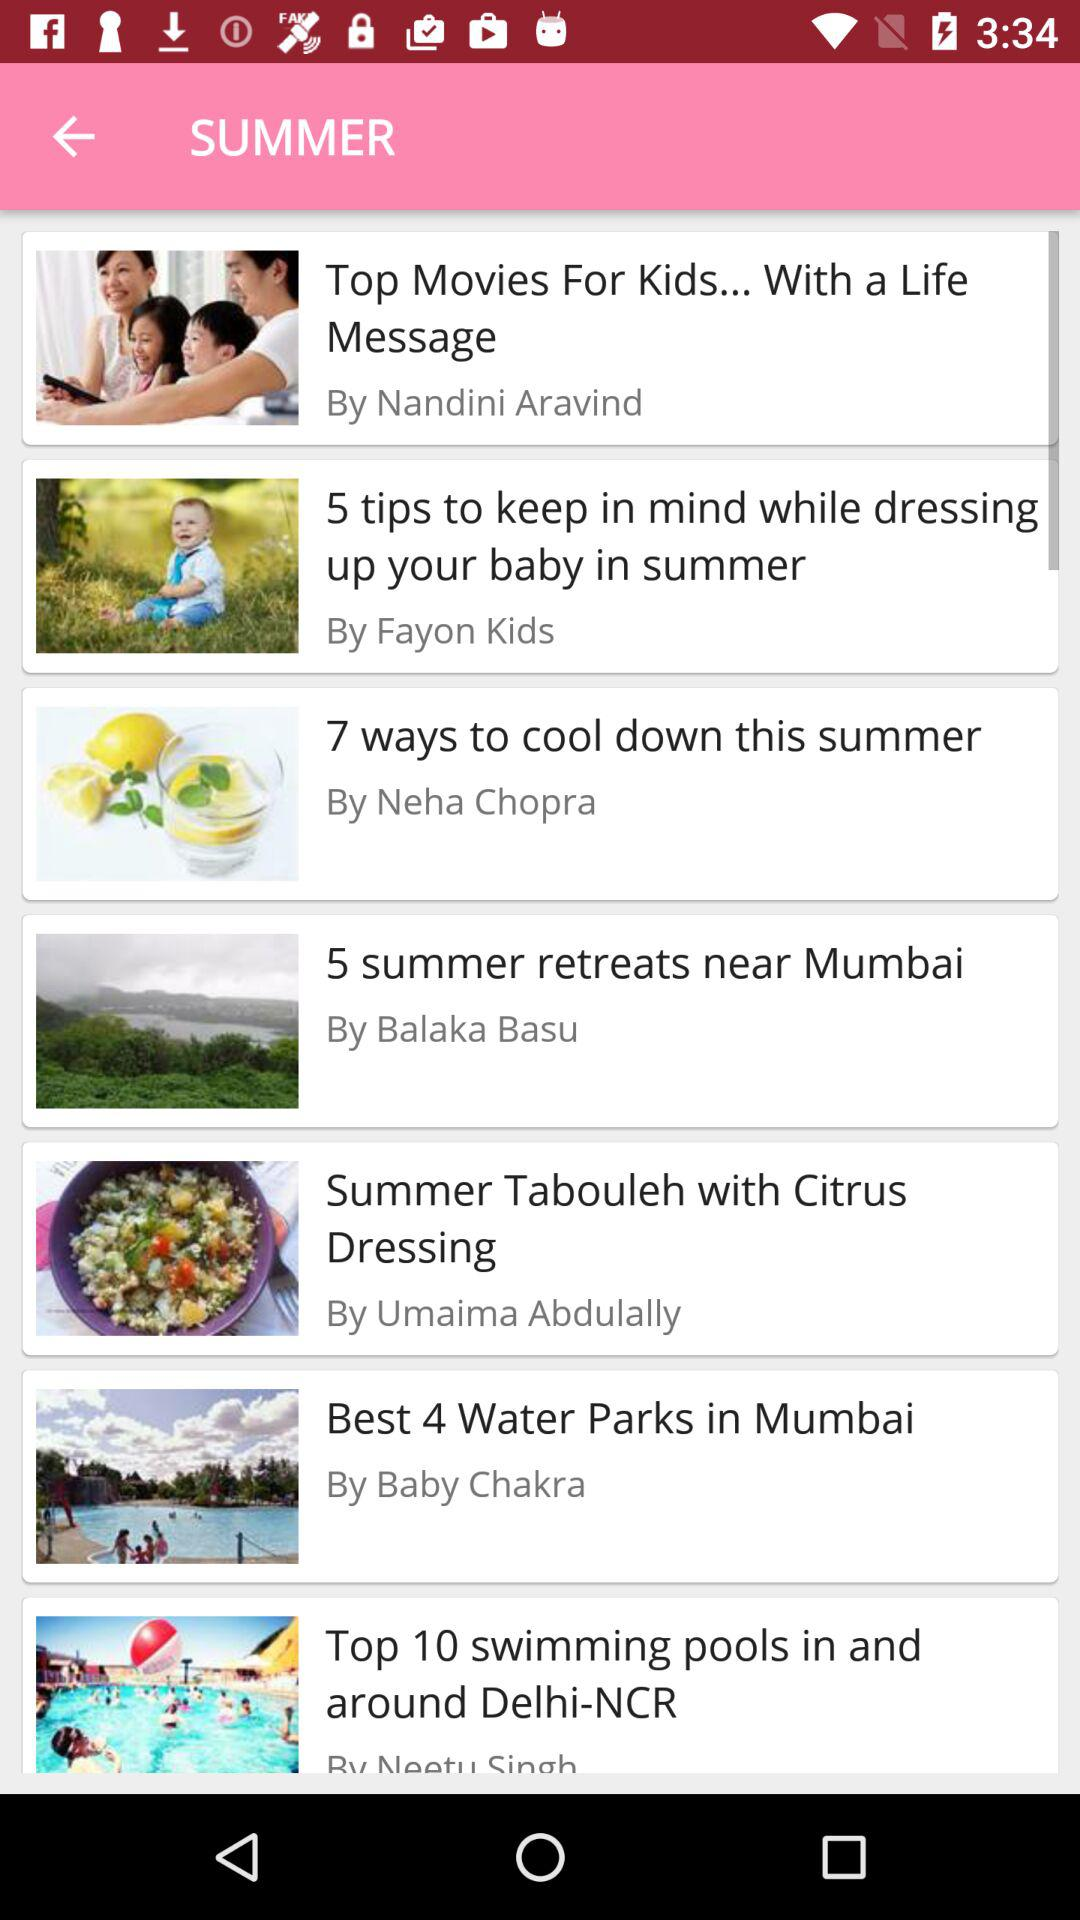How many ways are suggested to cool down this summer by Neha Chopra? Neha Chopra suggested seven ways to cool down this summer. 